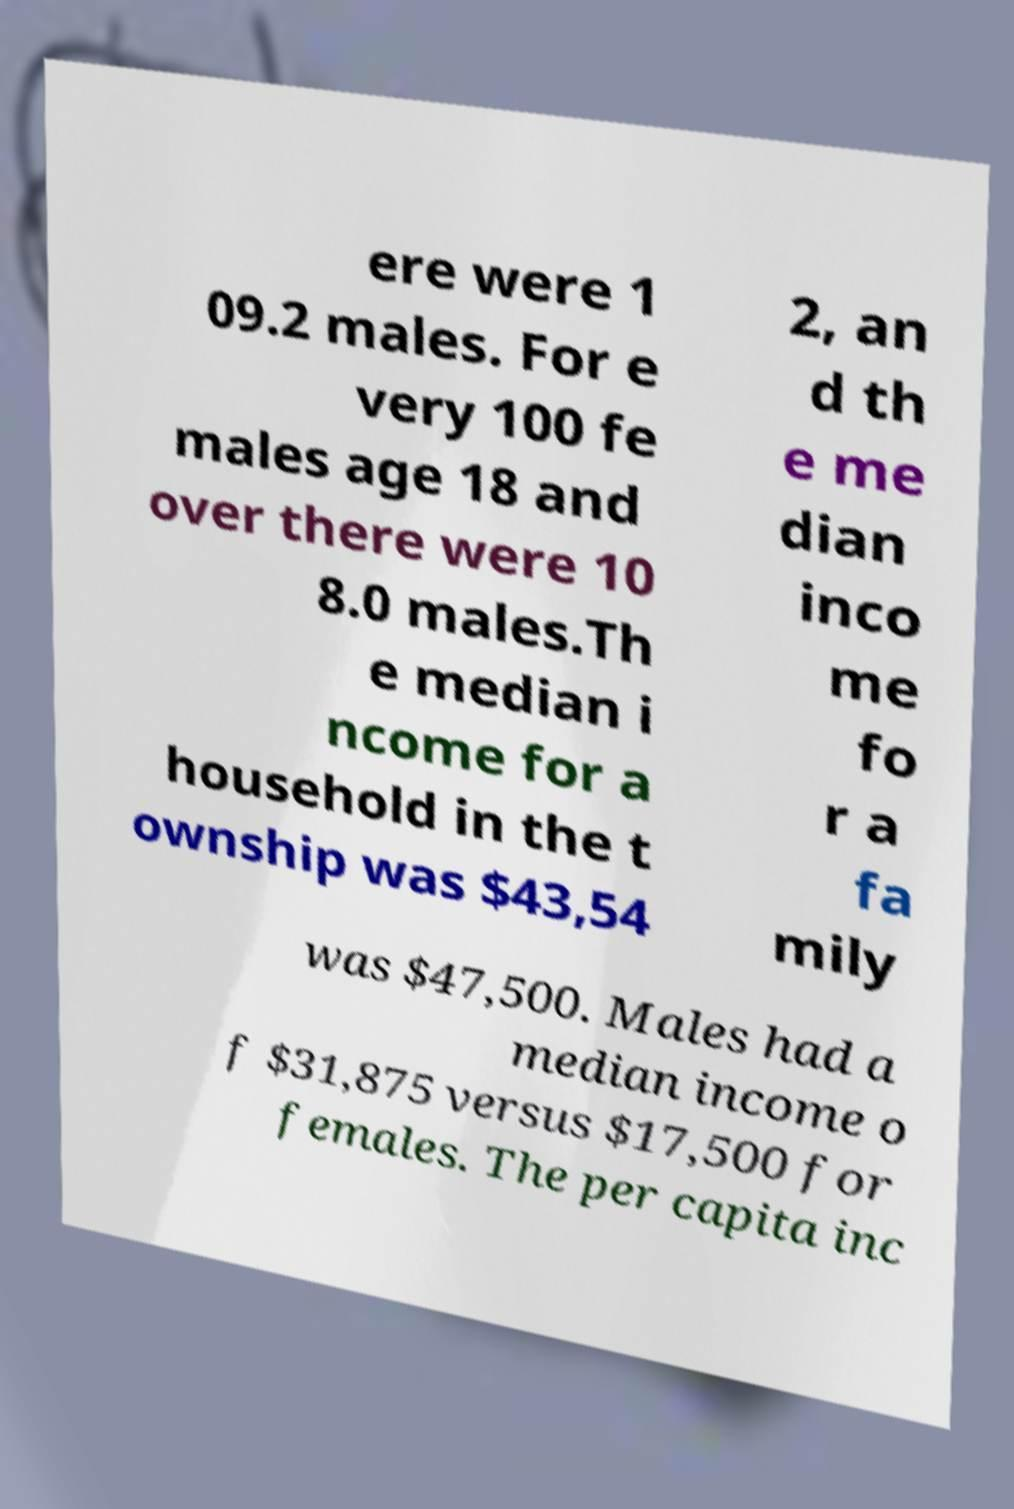Could you extract and type out the text from this image? ere were 1 09.2 males. For e very 100 fe males age 18 and over there were 10 8.0 males.Th e median i ncome for a household in the t ownship was $43,54 2, an d th e me dian inco me fo r a fa mily was $47,500. Males had a median income o f $31,875 versus $17,500 for females. The per capita inc 